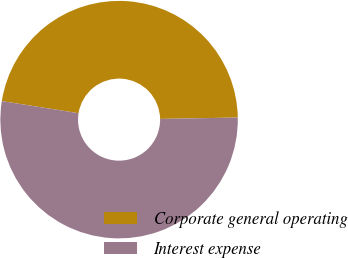<chart> <loc_0><loc_0><loc_500><loc_500><pie_chart><fcel>Corporate general operating<fcel>Interest expense<nl><fcel>47.22%<fcel>52.78%<nl></chart> 